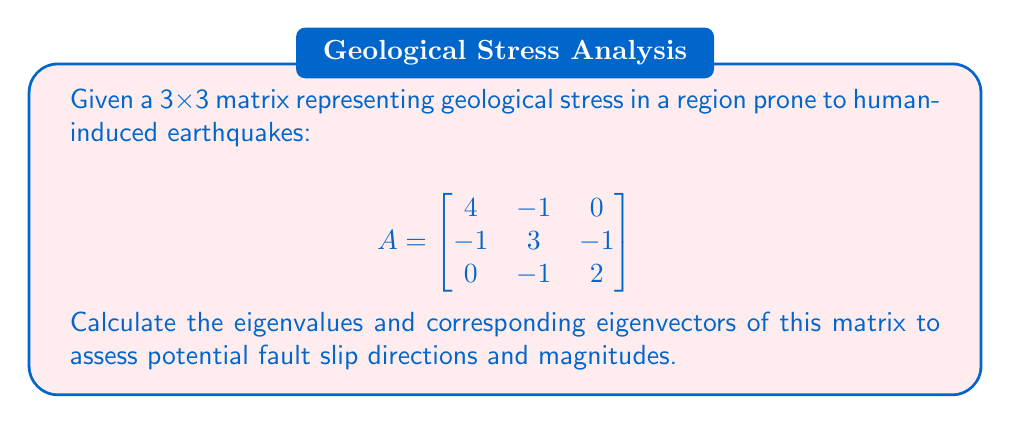Could you help me with this problem? 1. To find eigenvalues, solve the characteristic equation:
   $$\det(A - \lambda I) = 0$$

2. Expand the determinant:
   $$\begin{vmatrix}
   4-\lambda & -1 & 0 \\
   -1 & 3-\lambda & -1 \\
   0 & -1 & 2-\lambda
   \end{vmatrix} = 0$$

3. Simplify:
   $$(4-\lambda)(3-\lambda)(2-\lambda) - (4-\lambda) - (2-\lambda) = 0$$
   $$\lambda^3 - 9\lambda^2 + 24\lambda - 18 = 0$$

4. Factor the equation:
   $$(\lambda - 1)(\lambda - 2)(\lambda - 6) = 0$$

5. Eigenvalues are: $\lambda_1 = 1$, $\lambda_2 = 2$, $\lambda_3 = 6$

6. For each eigenvalue, find the corresponding eigenvector by solving $(A - \lambda I)v = 0$:

   For $\lambda_1 = 1$:
   $$\begin{bmatrix}
   3 & -1 & 0 \\
   -1 & 2 & -1 \\
   0 & -1 & 1
   \end{bmatrix}\begin{bmatrix}
   v_1 \\ v_2 \\ v_3
   \end{bmatrix} = \begin{bmatrix}
   0 \\ 0 \\ 0
   \end{bmatrix}$$
   Solving gives: $v_1 = 1$, $v_2 = 1$, $v_3 = 1$

   For $\lambda_2 = 2$:
   $$\begin{bmatrix}
   2 & -1 & 0 \\
   -1 & 1 & -1 \\
   0 & -1 & 0
   \end{bmatrix}\begin{bmatrix}
   v_1 \\ v_2 \\ v_3
   \end{bmatrix} = \begin{bmatrix}
   0 \\ 0 \\ 0
   \end{bmatrix}$$
   Solving gives: $v_1 = 1$, $v_2 = 2$, $v_3 = 2$

   For $\lambda_3 = 6$:
   $$\begin{bmatrix}
   -2 & -1 & 0 \\
   -1 & -3 & -1 \\
   0 & -1 & -4
   \end{bmatrix}\begin{bmatrix}
   v_1 \\ v_2 \\ v_3
   \end{bmatrix} = \begin{bmatrix}
   0 \\ 0 \\ 0
   \end{bmatrix}$$
   Solving gives: $v_1 = 2$, $v_2 = -1$, $v_3 = 1$

7. Normalize eigenvectors to unit length.
Answer: Eigenvalues: $\lambda_1 = 1$, $\lambda_2 = 2$, $\lambda_3 = 6$
Eigenvectors: $v_1 = \frac{1}{\sqrt{3}}(1,1,1)$, $v_2 = \frac{1}{\sqrt{9}}(1,2,2)$, $v_3 = \frac{1}{\sqrt{6}}(2,-1,1)$ 